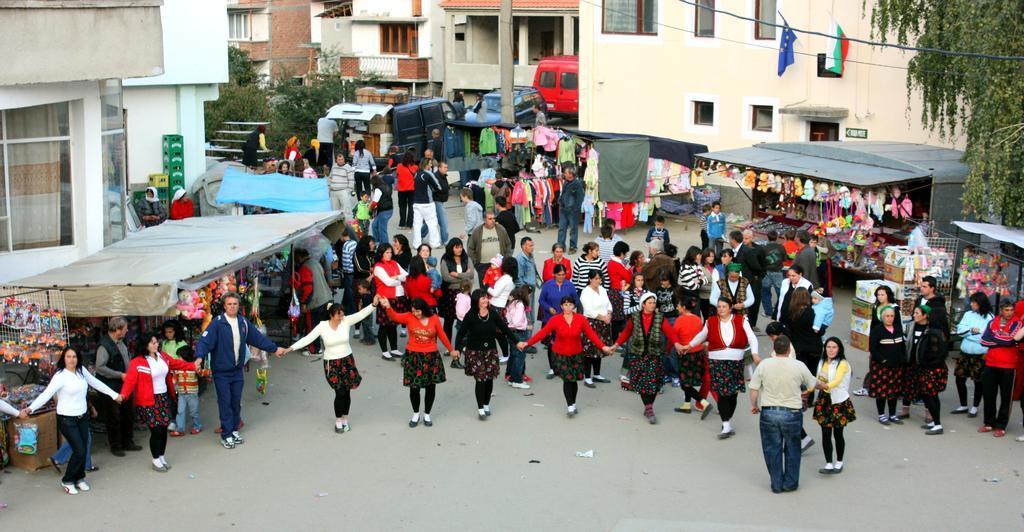Describe this image in one or two sentences. In the image in the center, we can see tents, clothes, toys, tables, boxes, vehicles and few people are standing. In the background, we can see buildings, windows, trees, flags, glass, wall, roof, curtain, pole, staircase, fence etc. 